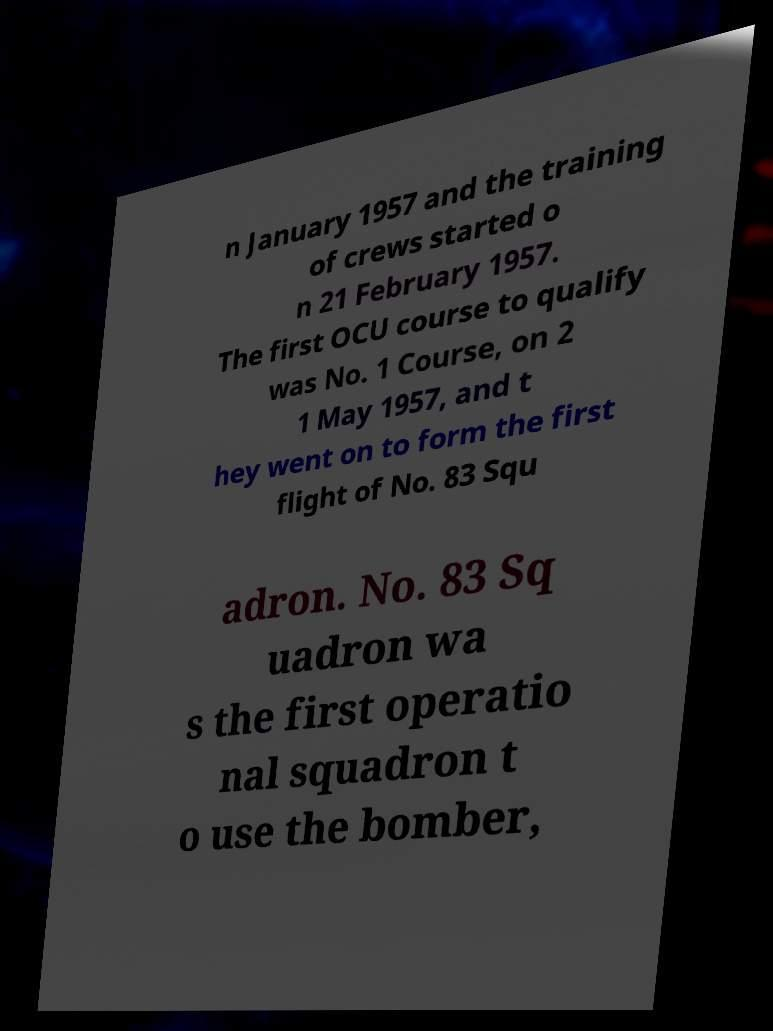There's text embedded in this image that I need extracted. Can you transcribe it verbatim? n January 1957 and the training of crews started o n 21 February 1957. The first OCU course to qualify was No. 1 Course, on 2 1 May 1957, and t hey went on to form the first flight of No. 83 Squ adron. No. 83 Sq uadron wa s the first operatio nal squadron t o use the bomber, 